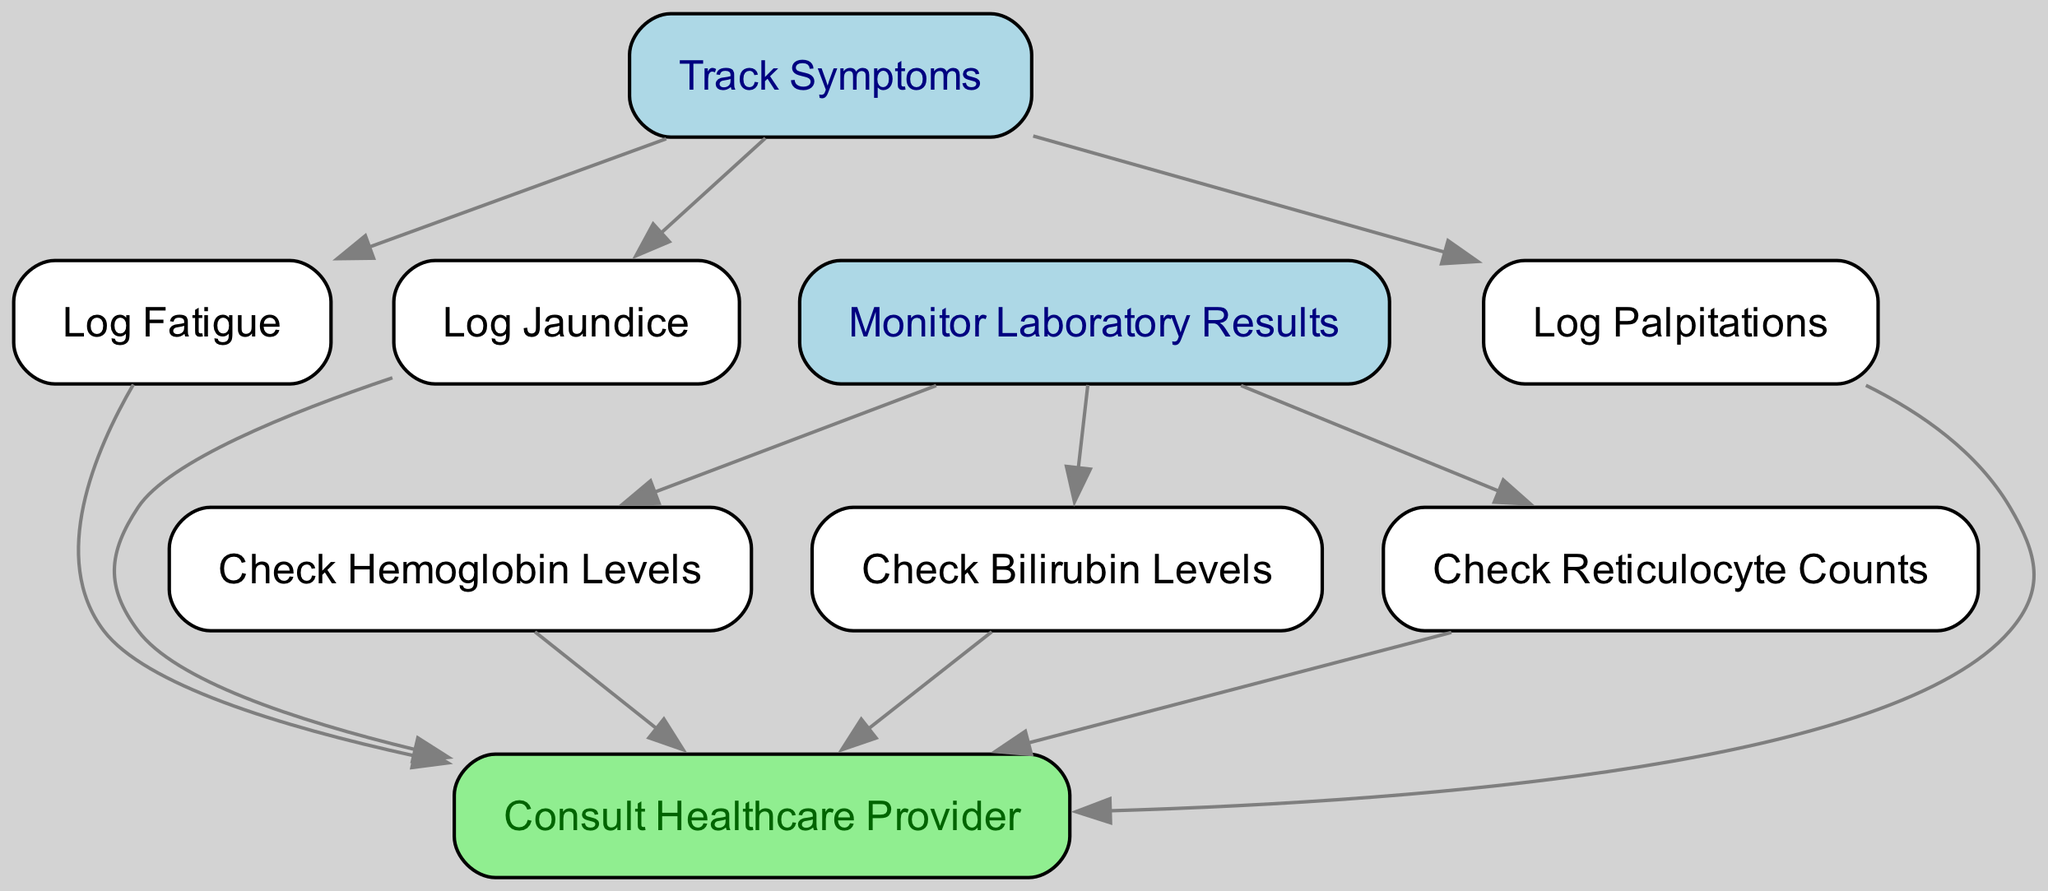What are the nodes that track symptoms? The diagram shows three nodes connected to "Track Symptoms": "Log Fatigue," "Log Jaundice," and "Log Palpitations." These nodes represent the specific symptoms that are monitored by the patient.
Answer: Log Fatigue, Log Jaundice, Log Palpitations How many lab results are monitored? There are three nodes connected to "Monitor Laboratory Results": "Check Hemoglobin Levels," "Check Bilirubin Levels," and "Check Reticulocyte Counts." Thus, the total number of nodes for lab results is three.
Answer: 3 What is the color of the "Consult Healthcare Provider" node? In the diagram, the "Consult Healthcare Provider" node is filled with light green color, distinguishing it from other nodes that represent symptoms and lab results.
Answer: Light green Which node is directly connected to both symptoms and lab results? The "Consult Healthcare Provider" node is directly connected to multiple nodes: "Log Fatigue," "Log Jaundice," "Log Palpitations," "Check Hemoglobin Levels," "Check Bilirubin Levels," and "Check Reticulocyte Counts," integrating both symptoms and lab results into one node.
Answer: Consult Healthcare Provider What is the purpose of the "Check Hemoglobin Levels" node? The "Check Hemoglobin Levels" node is meant to track hemoglobin levels over time to assess anemia status. It reflects an important aspect of monitoring lab results in managing pyruvate kinase deficiency.
Answer: Track hemoglobin levels over time What is the relationship between "Log Jaundice" and "Check Bilirubin Levels"? "Log Jaundice" and "Check Bilirubin Levels" are both connected through the main process of monitoring symptoms and lab results. There is an invisible edge indicating that monitoring jaundice is related to checking bilirubin levels.
Answer: Related monitoring How many nodes are included under "Track Symptoms"? The "Track Symptoms" block has three nodes connected to it: "Log Fatigue," "Log Jaundice," and "Log Palpitations," which totals to three nodes monitoring specific symptoms.
Answer: 3 What do you do after logging symptoms and checking lab results? After logging symptoms and checking lab results, the next step is to consult the healthcare provider. This step is crucial for discussing the tracked information for ongoing management of the condition.
Answer: Consult healthcare provider What is the primary focus of the "Monitor Laboratory Results" block? The "Monitor Laboratory Results" block focuses on regularly checking and documenting various laboratory results to effectively manage the patient’s condition, specifically hemoglobin, bilirubin, and reticulocyte levels.
Answer: Regularly check and document results 